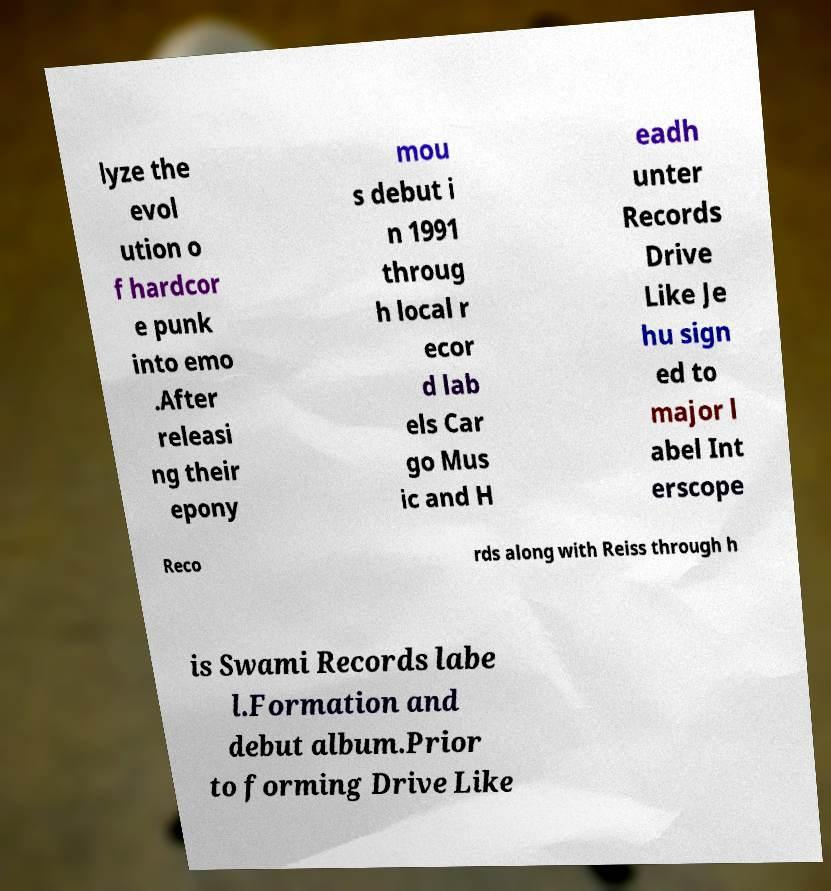Could you extract and type out the text from this image? lyze the evol ution o f hardcor e punk into emo .After releasi ng their epony mou s debut i n 1991 throug h local r ecor d lab els Car go Mus ic and H eadh unter Records Drive Like Je hu sign ed to major l abel Int erscope Reco rds along with Reiss through h is Swami Records labe l.Formation and debut album.Prior to forming Drive Like 